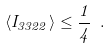<formula> <loc_0><loc_0><loc_500><loc_500>\langle I _ { 3 3 2 2 } \rangle \leq \frac { 1 } { 4 } \ .</formula> 